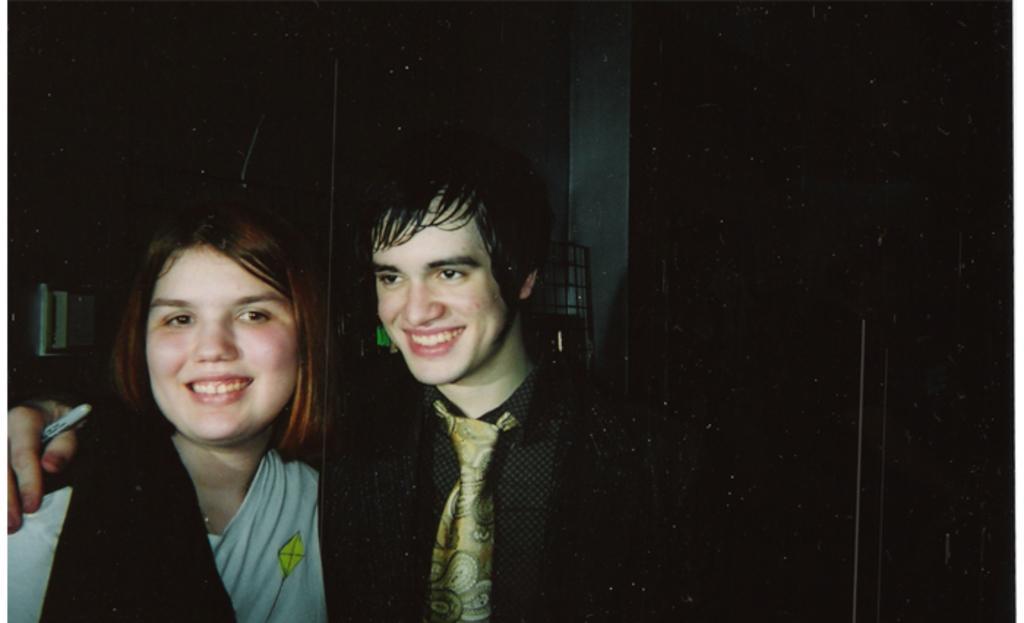Can you describe this image briefly? In this picture we can see two persons smiling here, a person on the right side wore a tie, there is a dark background. 